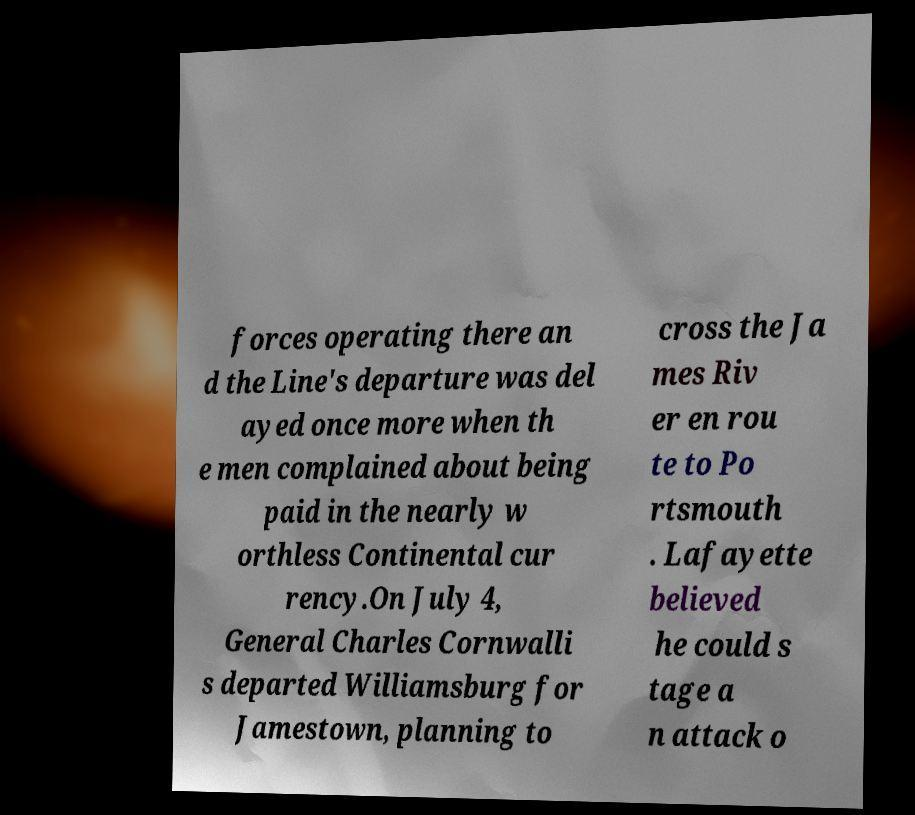Can you accurately transcribe the text from the provided image for me? forces operating there an d the Line's departure was del ayed once more when th e men complained about being paid in the nearly w orthless Continental cur rency.On July 4, General Charles Cornwalli s departed Williamsburg for Jamestown, planning to cross the Ja mes Riv er en rou te to Po rtsmouth . Lafayette believed he could s tage a n attack o 